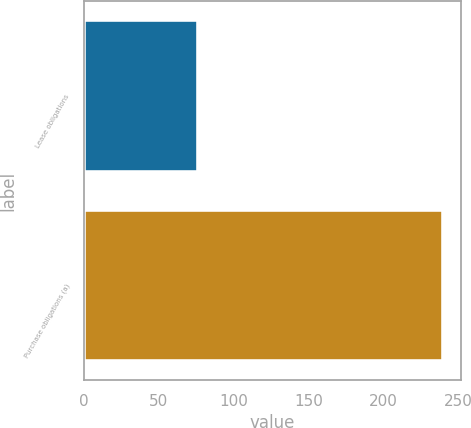Convert chart. <chart><loc_0><loc_0><loc_500><loc_500><bar_chart><fcel>Lease obligations<fcel>Purchase obligations (a)<nl><fcel>76<fcel>240<nl></chart> 